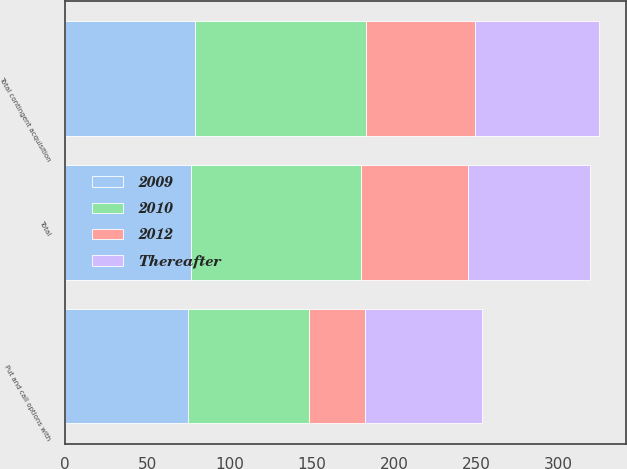Convert chart. <chart><loc_0><loc_0><loc_500><loc_500><stacked_bar_chart><ecel><fcel>Put and call options with<fcel>Total contingent acquisition<fcel>Total<nl><fcel>2009<fcel>74.6<fcel>79.3<fcel>76.7<nl><fcel>2012<fcel>34.3<fcel>66.4<fcel>65.1<nl><fcel>2010<fcel>73.6<fcel>103.7<fcel>103<nl><fcel>Thereafter<fcel>70.8<fcel>75.3<fcel>74.6<nl></chart> 